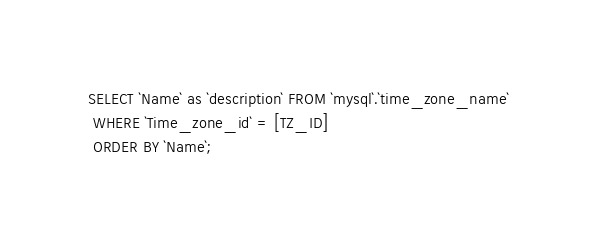<code> <loc_0><loc_0><loc_500><loc_500><_SQL_>SELECT `Name` as `description` FROM `mysql`.`time_zone_name`
 WHERE `Time_zone_id` = [TZ_ID]
 ORDER BY `Name`;</code> 